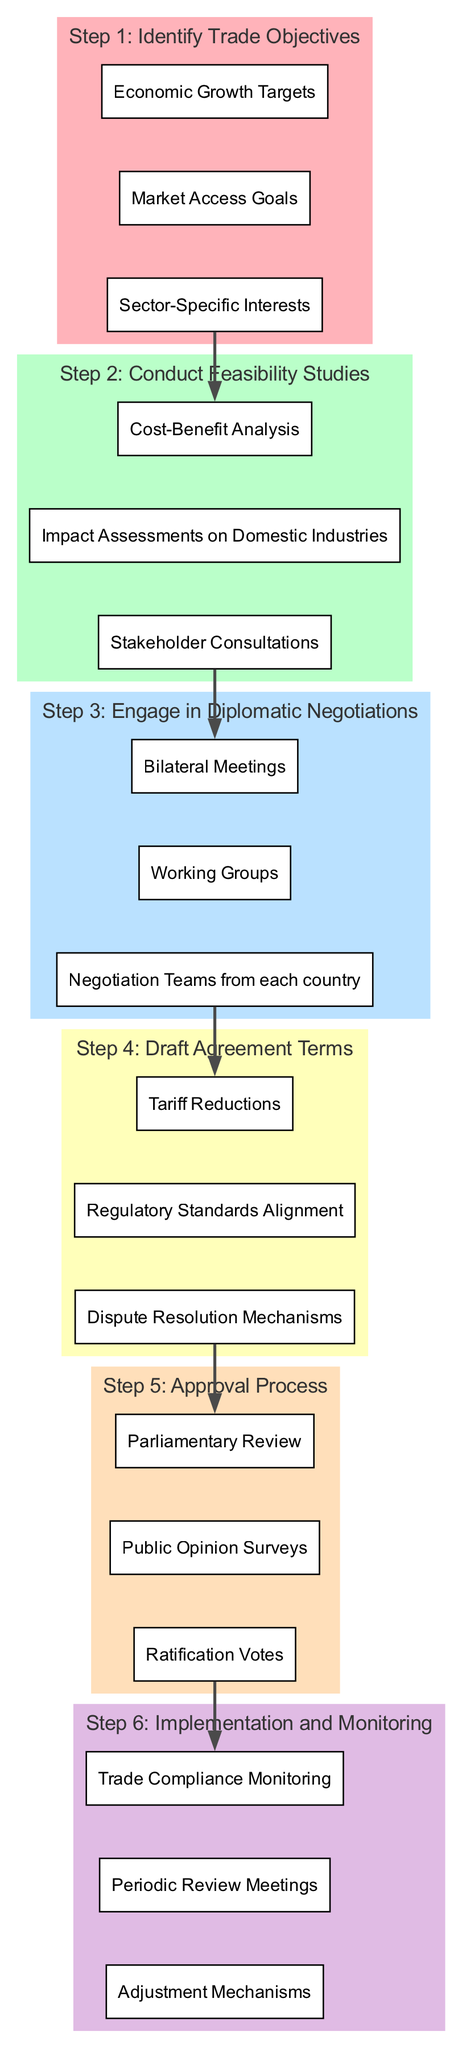What is the description of Step 3? The description is "Engage in Diplomatic Negotiations." This can be found labeled within the cluster of Step 3 in the diagram, which directly states the action involved in that specific step.
Answer: Engage in Diplomatic Negotiations How many entities are listed under Step 2? There are three entities under Step 2, which are "Cost-Benefit Analysis," "Impact Assessments on Domestic Industries," and "Stakeholder Consultations." I counted each entity listed within the cluster of Step 2.
Answer: 3 What is the final step in the process? The final step is "Implementation and Monitoring," which is stated clearly as Step 6 in the diagram.
Answer: Implementation and Monitoring Which step precedes the drafting of agreement terms? Step 3, which is "Engage in Diplomatic Negotiations," precedes Step 4. This can be determined by following the flow in the diagram from Step 3 to Step 4.
Answer: Engage in Diplomatic Negotiations What type of analysis is conducted in Step 2? A "Cost-Benefit Analysis" is conducted in Step 2. This is one of the entities listed under that step in the diagram.
Answer: Cost-Benefit Analysis How many steps are there in total? There are six steps in total, denoted as Step 1 through Step 6 in the diagram. I counted each labeled step representing phases in the decision-making process.
Answer: 6 Which elements fall under the approval process? The entities under the approval process are "Parliamentary Review," "Public Opinion Surveys," and "Ratification Votes." These are listed within the cluster of Step 5 in the diagram.
Answer: Parliamentary Review, Public Opinion Surveys, Ratification Votes What is the relationship between Step 4 and Step 5? Step 4, which involves "Draft Agreement Terms," directly leads into Step 5, indicating that after drafting, the approval process occurs. This can be understood from the arrows connecting Step 4 to Step 5 in the diagram.
Answer: Leads into What is a key component of Step 6? A key component is "Trade Compliance Monitoring," which is one of the entities included in the Implementation and Monitoring phase outlined in Step 6.
Answer: Trade Compliance Monitoring 